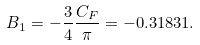Convert formula to latex. <formula><loc_0><loc_0><loc_500><loc_500>B _ { 1 } = - \frac { 3 } { 4 } \frac { C _ { F } } { \pi } = - 0 . 3 1 8 3 1 .</formula> 